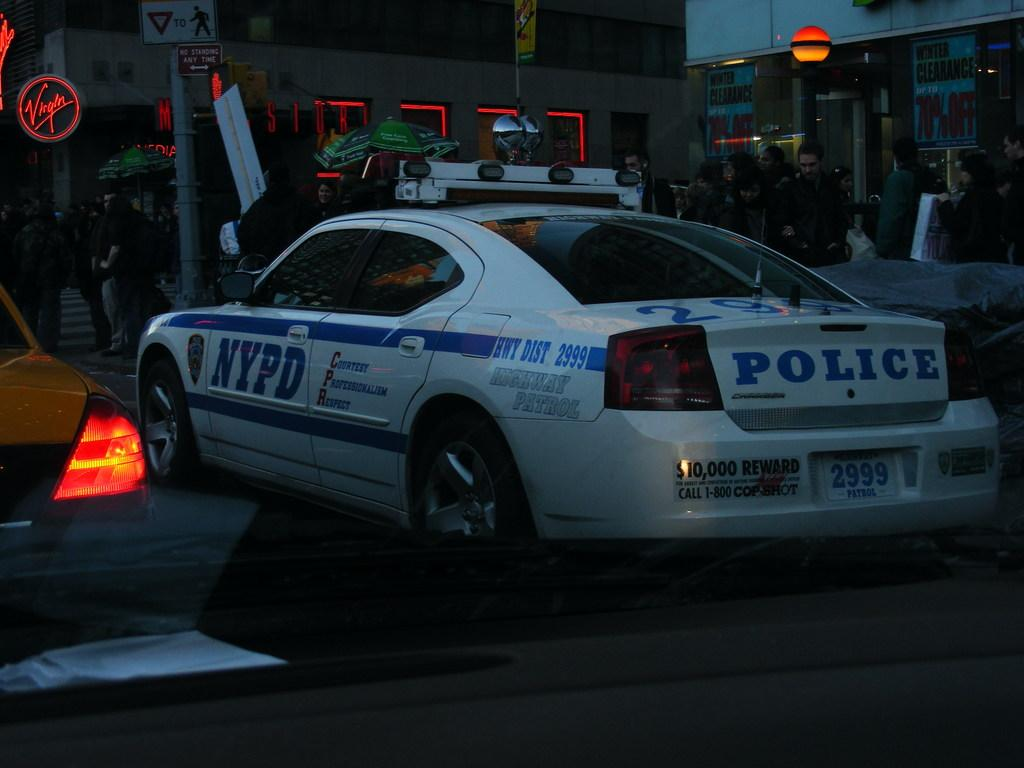What is the overall lighting condition in the image? The image is dark. What types of objects can be seen on the ground in the image? There are vehicles on the ground in the image. Are there any people present in the image? Yes, there are people standing in the image. What kind of structures are visible in the image? There are buildings in the image. What sources of light can be seen in the image? There are lights in the image. What other objects can be seen in the image besides vehicles, people, and buildings? There are boards and a pole in the image. Can you see a wall made of bricks in the image? There is no wall made of bricks visible in the image. What type of wave is being created by the people in the image? There are no waves being created by the people in the image. What kind of drum is being played by the people in the image? There are no drums being played by the people in the image. 